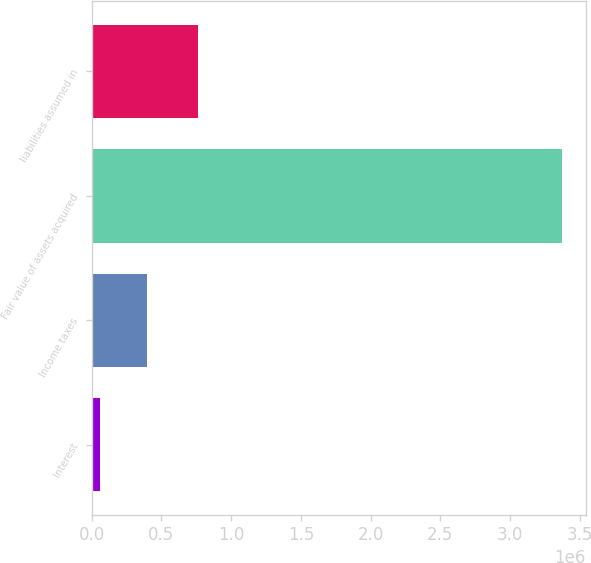Convert chart. <chart><loc_0><loc_0><loc_500><loc_500><bar_chart><fcel>Interest<fcel>Income taxes<fcel>Fair value of assets acquired<fcel>liabilities assumed in<nl><fcel>61468<fcel>392882<fcel>3.3756e+06<fcel>762076<nl></chart> 